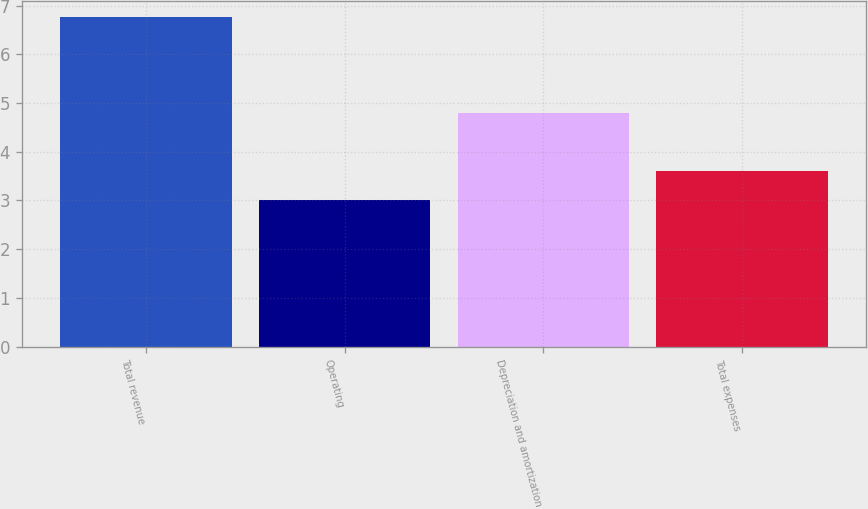<chart> <loc_0><loc_0><loc_500><loc_500><bar_chart><fcel>Total revenue<fcel>Operating<fcel>Depreciation and amortization<fcel>Total expenses<nl><fcel>6.76<fcel>3.01<fcel>4.8<fcel>3.6<nl></chart> 